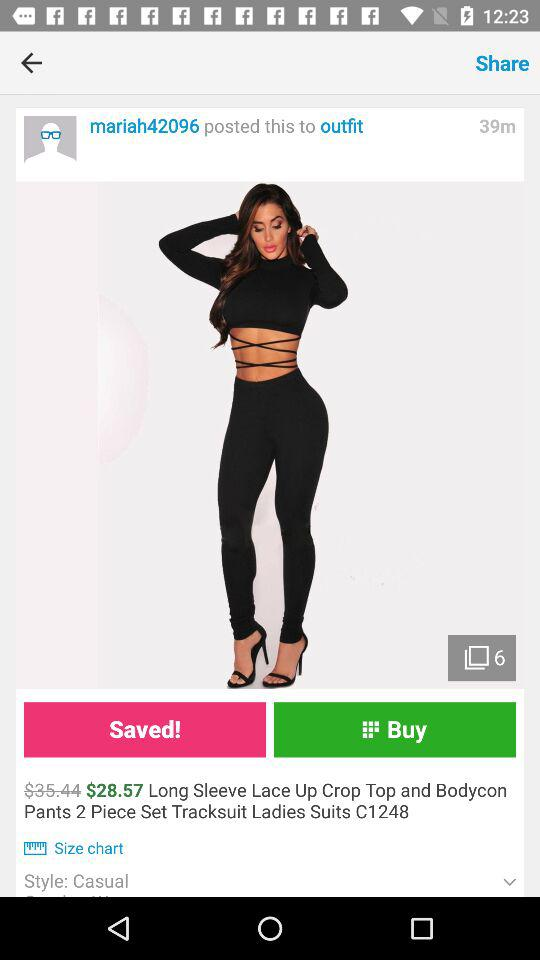Which style has been mentioned for the product? The style that has been mentioned is casual. 